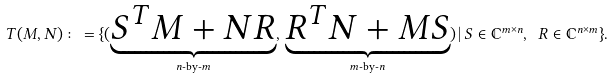<formula> <loc_0><loc_0><loc_500><loc_500>T ( M , N ) \colon = \{ ( \underbrace { S ^ { T } M + N R } _ { \text {$n$-by-$m$} } , \, \underbrace { R ^ { T } N + M S } _ { \text {$m$-by-$n$} } ) \, | \, S \in { \mathbb { C } } ^ { m \times n } , \ R \in { \mathbb { C } } ^ { n \times m } \} .</formula> 